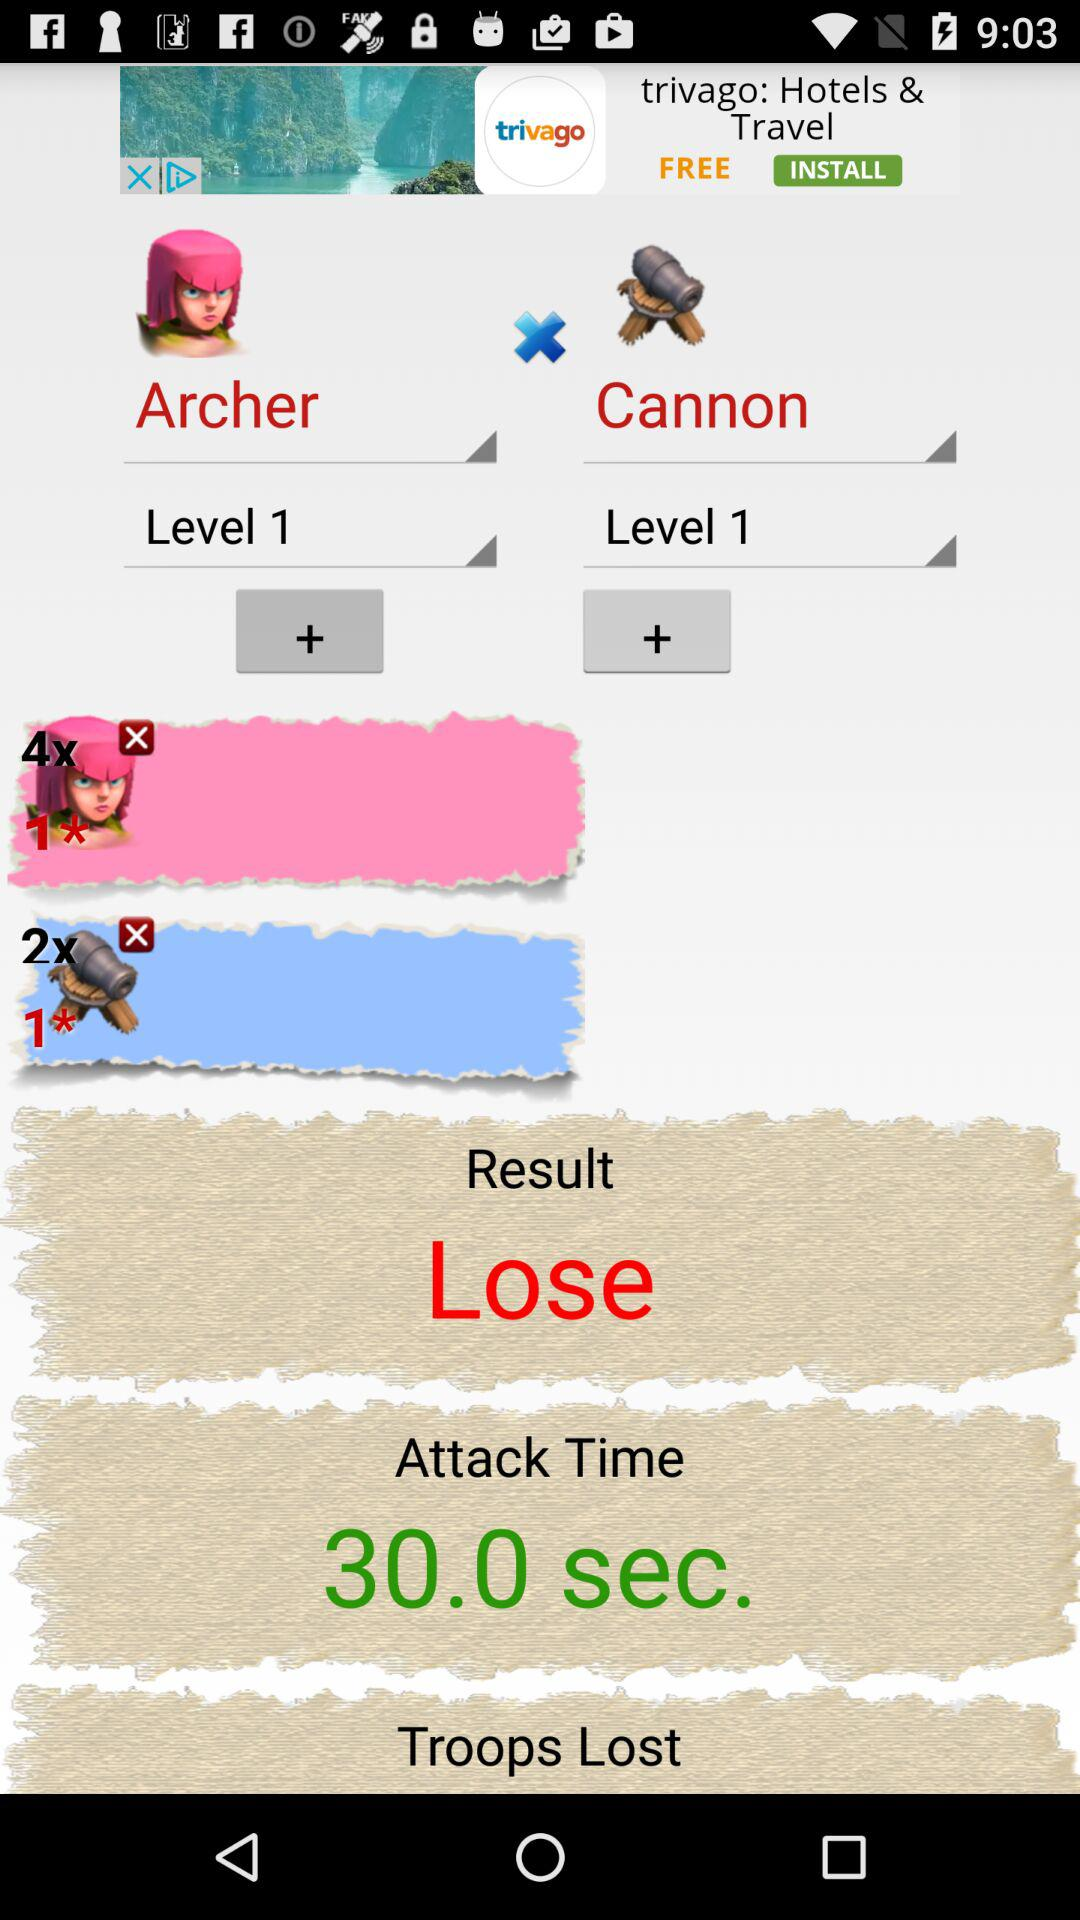What was the result? The result was "Lose". 